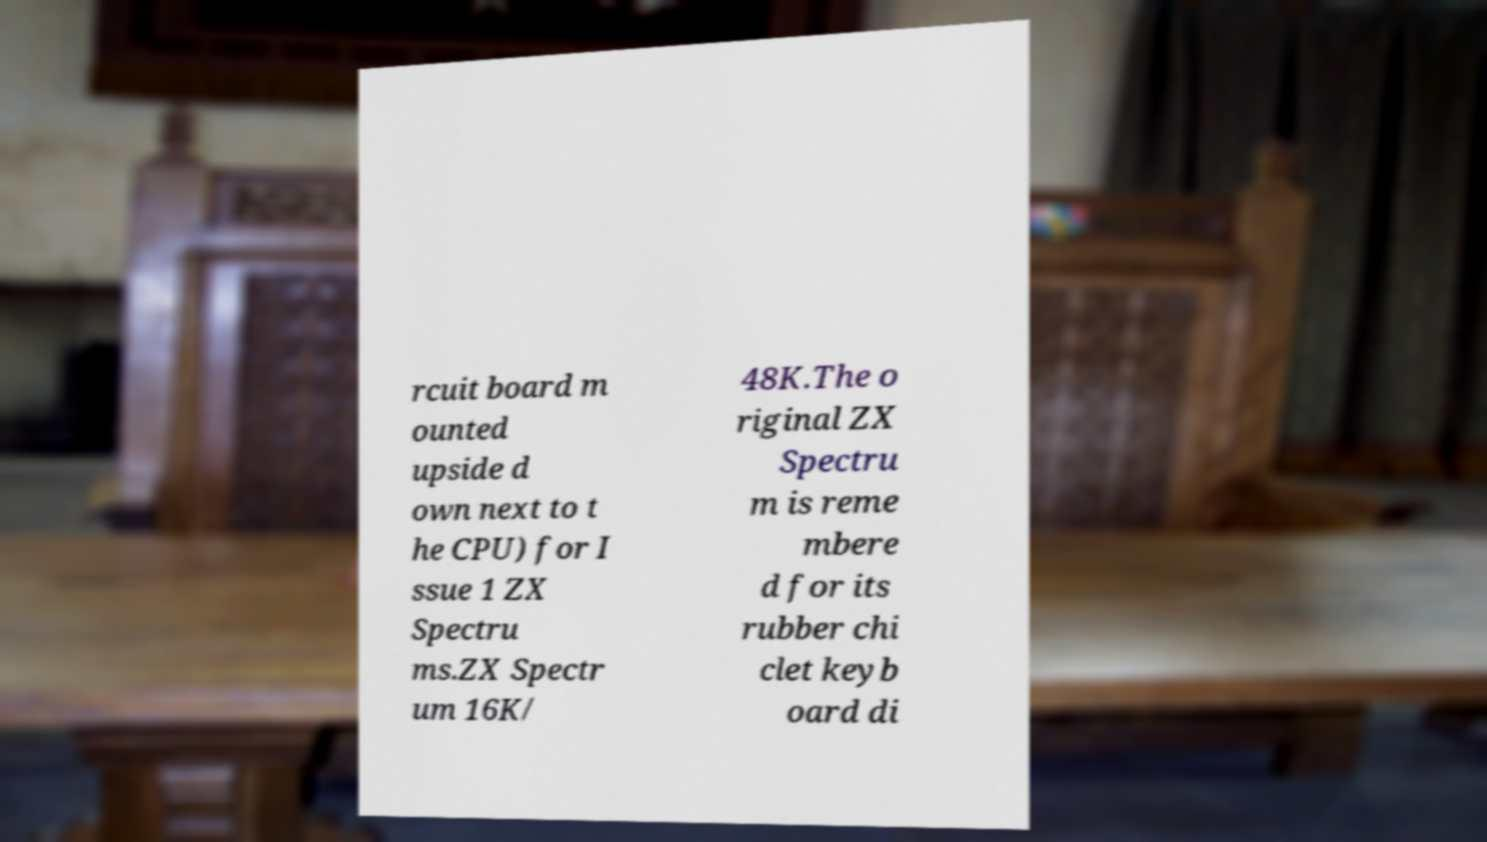Can you accurately transcribe the text from the provided image for me? rcuit board m ounted upside d own next to t he CPU) for I ssue 1 ZX Spectru ms.ZX Spectr um 16K/ 48K.The o riginal ZX Spectru m is reme mbere d for its rubber chi clet keyb oard di 